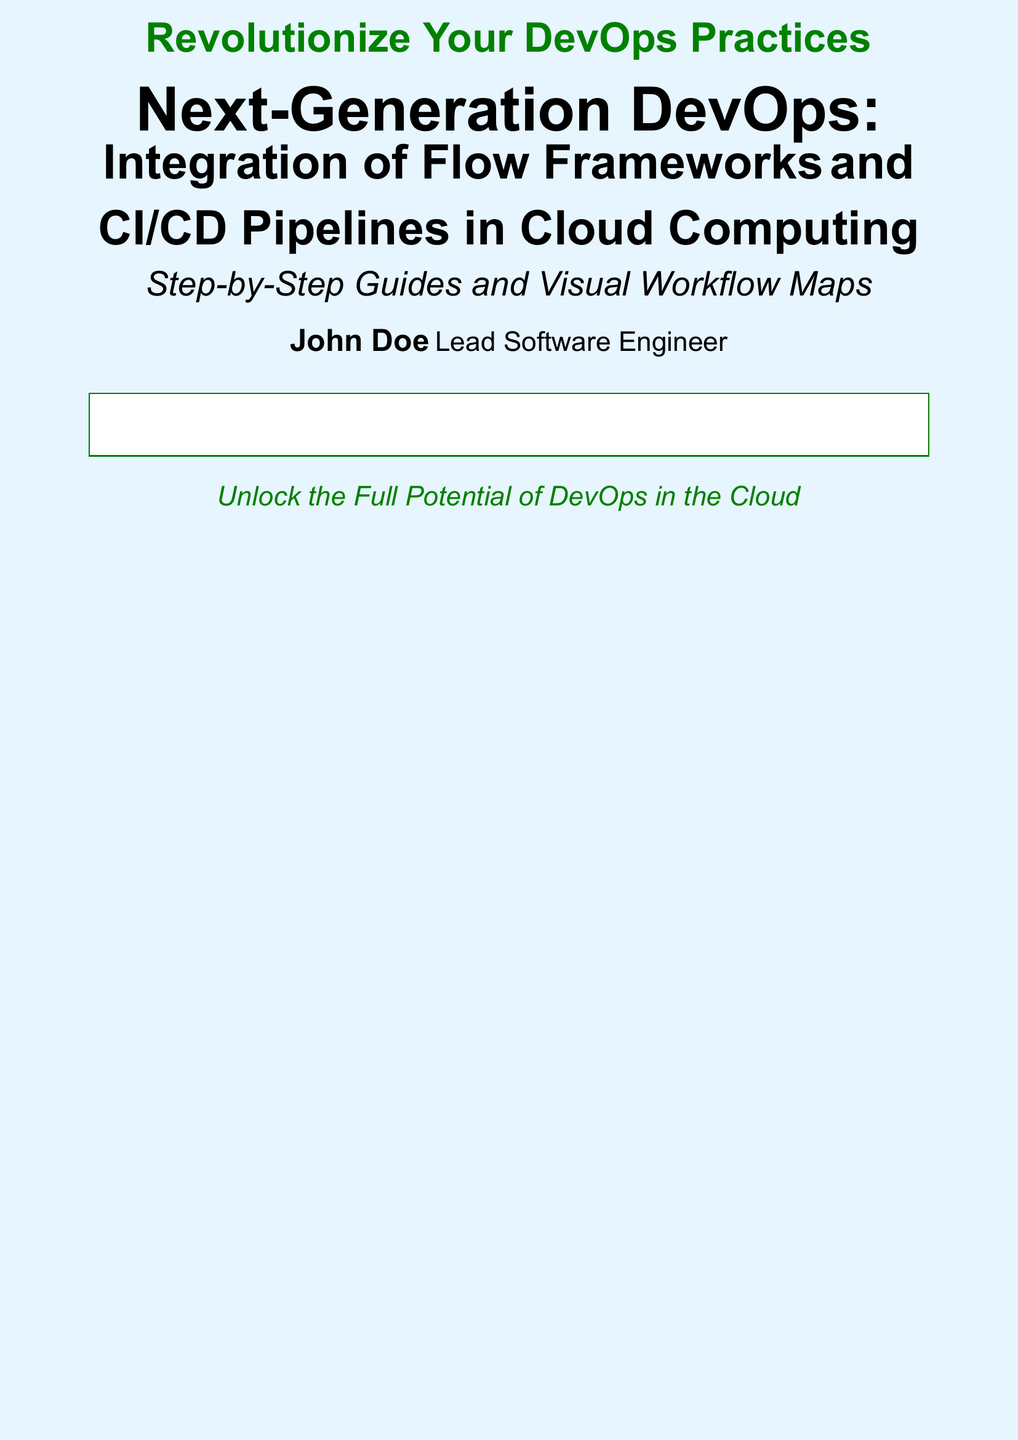What is the title of the book? The title is prominently displayed in the document and indicates the main subject.
Answer: Next-Generation DevOps: Integration of Flow Frameworks and CI/CD Pipelines in Cloud Computing Who is the author of the book? The author's name is listed near the bottom of the cover, indicating who has written the work.
Answer: John Doe What role does the author hold? The author's professional title is mentioned, giving insight into their expertise.
Answer: Lead Software Engineer What is one of the main subjects discussed in the book? The book covers several key areas, one of which is highlighted in the introduction section.
Answer: Flow Frameworks Which tool is mentioned for CI/CD pipelines? The document lists popular tools used in CI/CD pipelines as part of the content overview.
Answer: Jenkins 